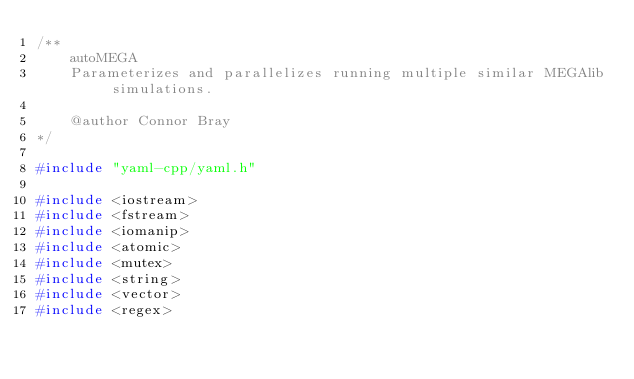Convert code to text. <code><loc_0><loc_0><loc_500><loc_500><_C++_>/**
    autoMEGA
    Parameterizes and parallelizes running multiple similar MEGAlib simulations.

    @author Connor Bray
*/

#include "yaml-cpp/yaml.h"

#include <iostream>
#include <fstream>
#include <iomanip>
#include <atomic>
#include <mutex>
#include <string>
#include <vector>
#include <regex></code> 